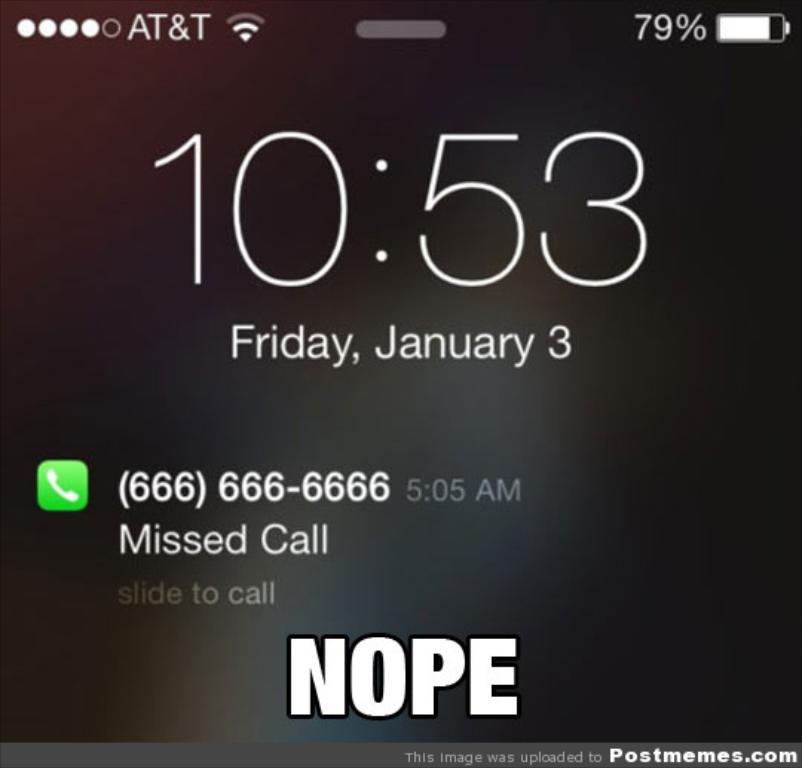What day was this screenshot taken?
Keep it short and to the point. Friday. What is the phone number of the missed call?
Ensure brevity in your answer.  (666) 666-6666. 